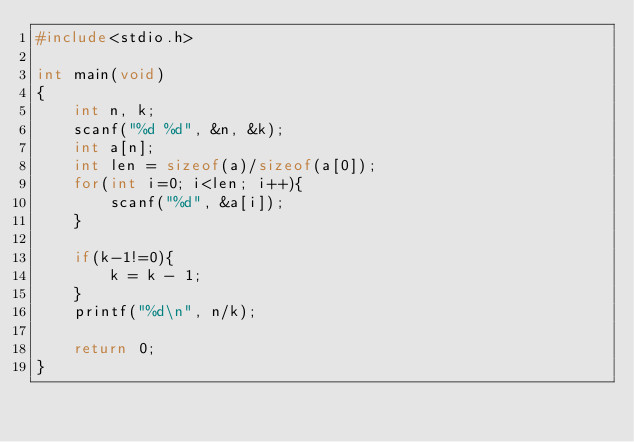<code> <loc_0><loc_0><loc_500><loc_500><_C_>#include<stdio.h>

int main(void)
{
    int n, k;
    scanf("%d %d", &n, &k);
    int a[n];
    int len = sizeof(a)/sizeof(a[0]);
    for(int i=0; i<len; i++){
        scanf("%d", &a[i]);
    }

    if(k-1!=0){
        k = k - 1;
    }
    printf("%d\n", n/k);

    return 0;
}</code> 